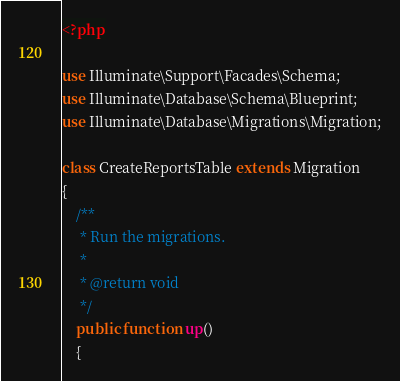Convert code to text. <code><loc_0><loc_0><loc_500><loc_500><_PHP_><?php

use Illuminate\Support\Facades\Schema;
use Illuminate\Database\Schema\Blueprint;
use Illuminate\Database\Migrations\Migration;

class CreateReportsTable extends Migration
{
    /**
     * Run the migrations.
     *
     * @return void
     */
    public function up()
    {</code> 